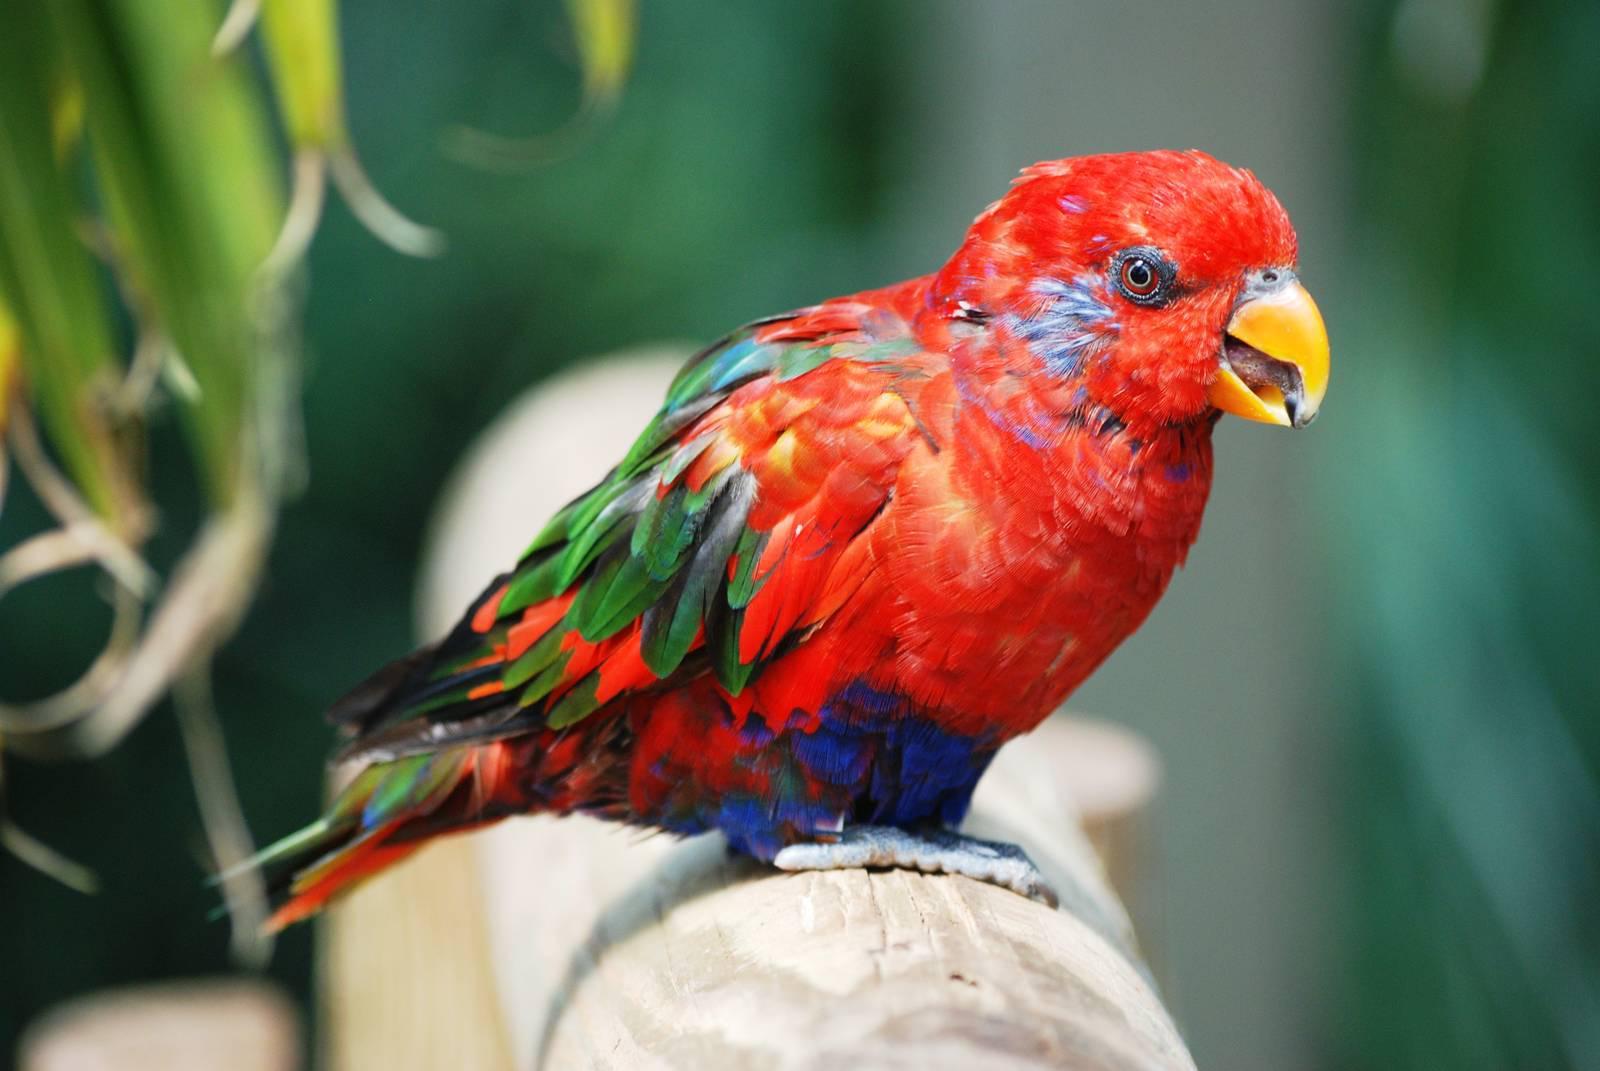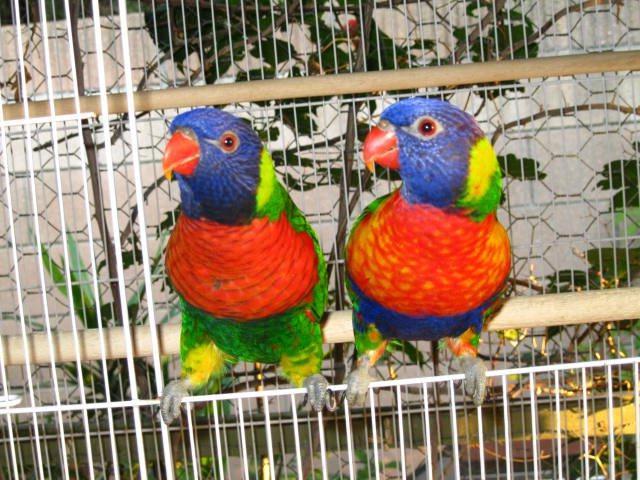The first image is the image on the left, the second image is the image on the right. Considering the images on both sides, is "Every bird has a head that is more than half blue." valid? Answer yes or no. No. 